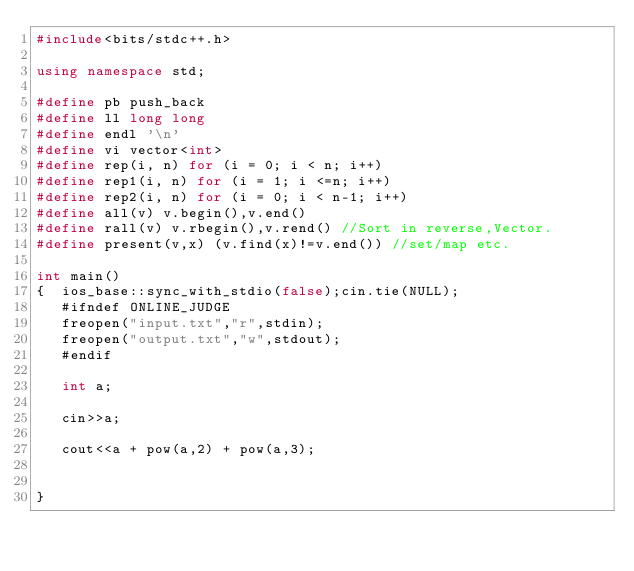<code> <loc_0><loc_0><loc_500><loc_500><_C++_>#include<bits/stdc++.h>
 
using namespace std;
 
#define pb push_back
#define ll long long
#define endl '\n'
#define vi vector<int>
#define rep(i, n) for (i = 0; i < n; i++)
#define rep1(i, n) for (i = 1; i <=n; i++)
#define rep2(i, n) for (i = 0; i < n-1; i++)
#define all(v) v.begin(),v.end()
#define rall(v) v.rbegin(),v.rend() //Sort in reverse,Vector.
#define present(v,x) (v.find(x)!=v.end()) //set/map etc.

int main()
{  ios_base::sync_with_stdio(false);cin.tie(NULL);
   #ifndef ONLINE_JUDGE
   freopen("input.txt","r",stdin);
   freopen("output.txt","w",stdout);
   #endif

   int a;

   cin>>a;

   cout<<a + pow(a,2) + pow(a,3);
  
   
}  
   


</code> 